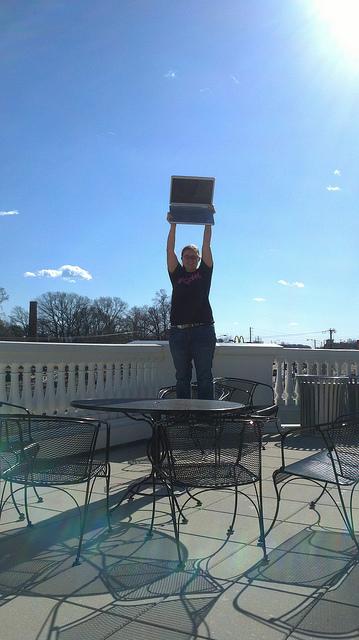Is there a body of water?
Be succinct. No. What is the artistic device doing here in the space?
Answer briefly. Nothing. What is the woman holding?
Write a very short answer. Laptop. Is this woman indoors?
Short answer required. No. Is the girl standing on a table?
Answer briefly. No. 